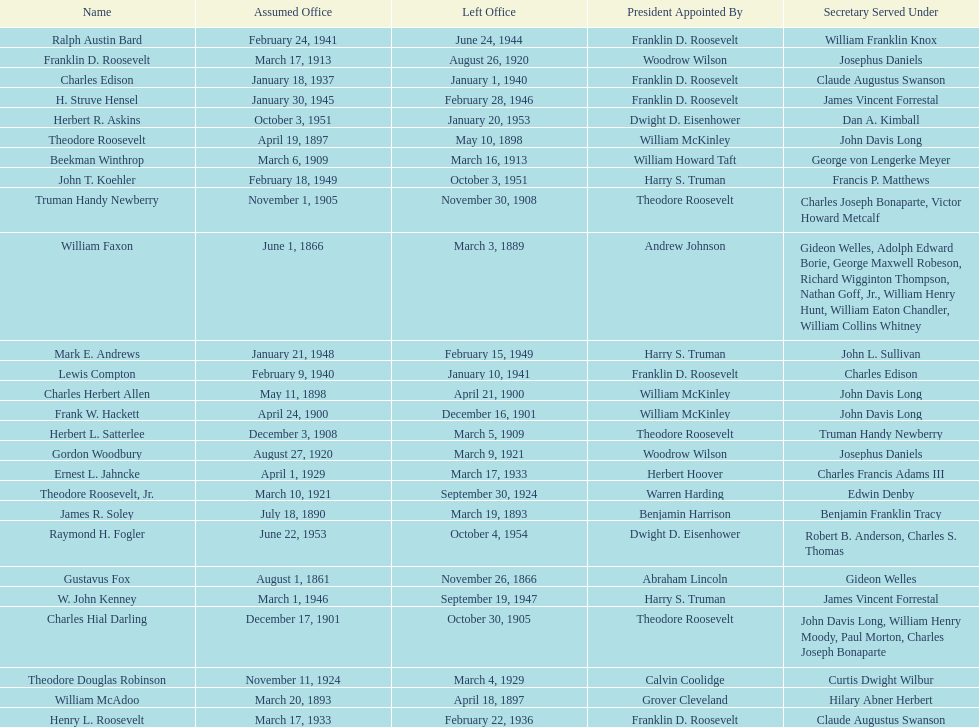Who was the first assistant secretary of the navy? Gustavus Fox. 